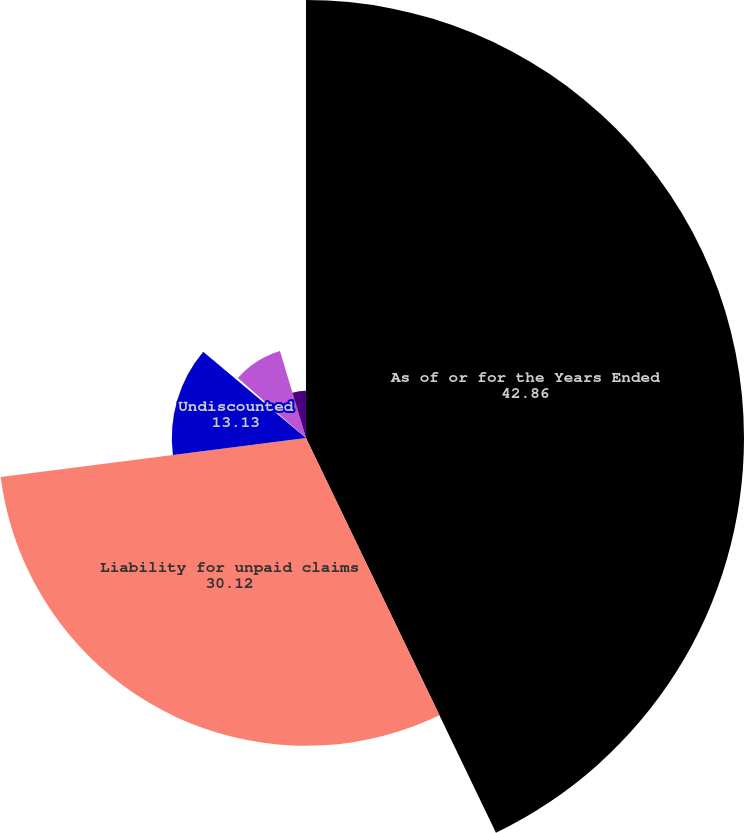<chart> <loc_0><loc_0><loc_500><loc_500><pie_chart><fcel>As of or for the Years Ended<fcel>Liability for unpaid claims<fcel>Undiscounted<fcel>Change in discount<fcel>Losses and loss expenses<fcel>Losses and loss expenses paid<nl><fcel>42.86%<fcel>30.12%<fcel>13.13%<fcel>0.38%<fcel>8.88%<fcel>4.63%<nl></chart> 